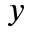Convert formula to latex. <formula><loc_0><loc_0><loc_500><loc_500>y</formula> 